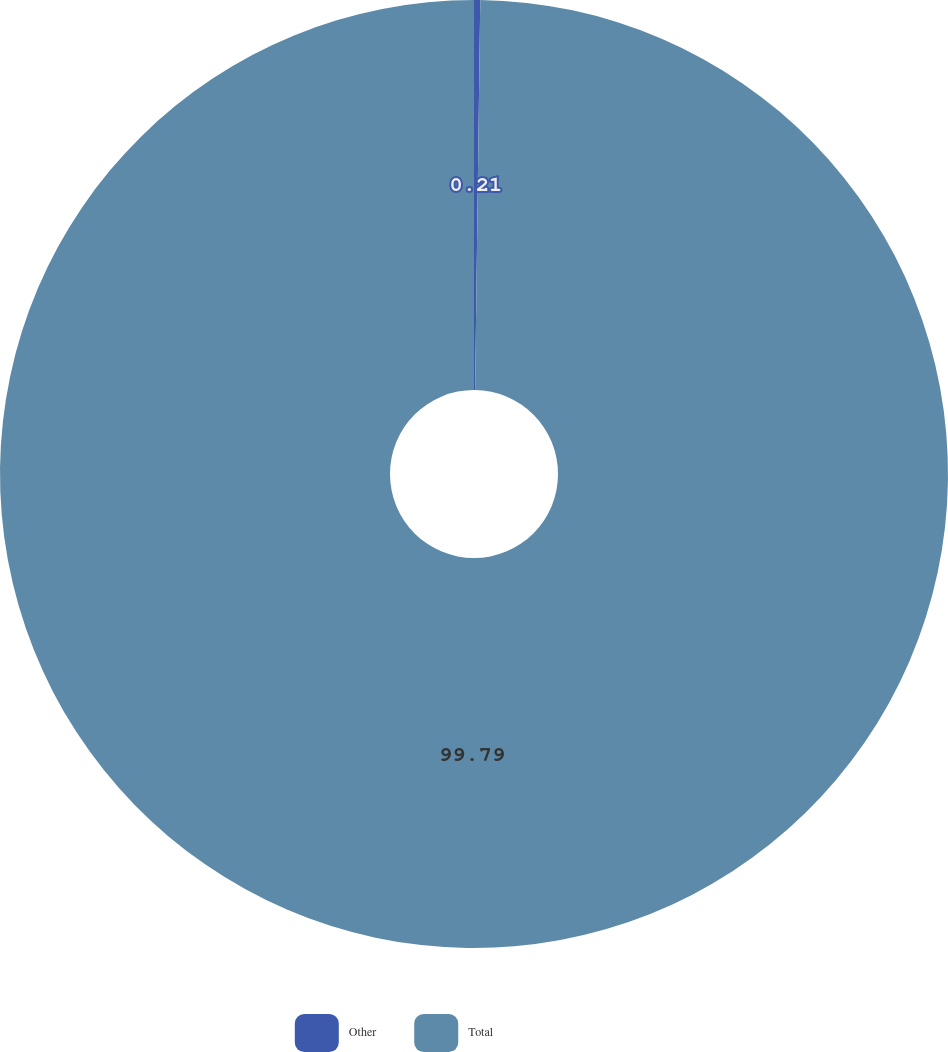<chart> <loc_0><loc_0><loc_500><loc_500><pie_chart><fcel>Other<fcel>Total<nl><fcel>0.21%<fcel>99.79%<nl></chart> 